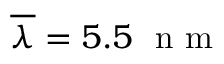Convert formula to latex. <formula><loc_0><loc_0><loc_500><loc_500>\overline { \lambda } = 5 . 5 n m</formula> 